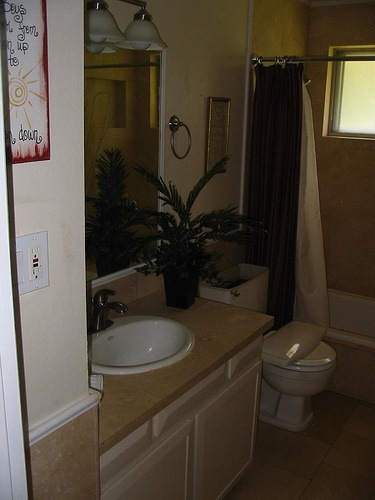Describe the objects in this image and their specific colors. I can see potted plant in black and gray tones, toilet in black and gray tones, and sink in black and gray tones in this image. 